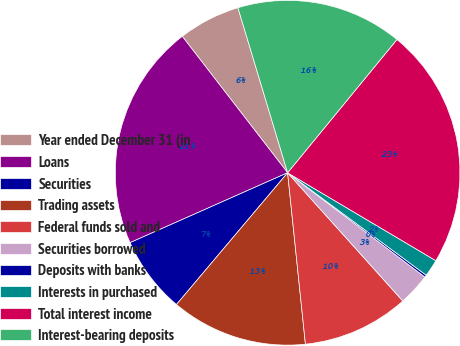Convert chart. <chart><loc_0><loc_0><loc_500><loc_500><pie_chart><fcel>Year ended December 31 (in<fcel>Loans<fcel>Securities<fcel>Trading assets<fcel>Federal funds sold and<fcel>Securities borrowed<fcel>Deposits with banks<fcel>Interests in purchased<fcel>Total interest income<fcel>Interest-bearing deposits<nl><fcel>5.81%<fcel>21.18%<fcel>7.2%<fcel>12.8%<fcel>10.0%<fcel>3.01%<fcel>0.21%<fcel>1.61%<fcel>22.58%<fcel>15.59%<nl></chart> 